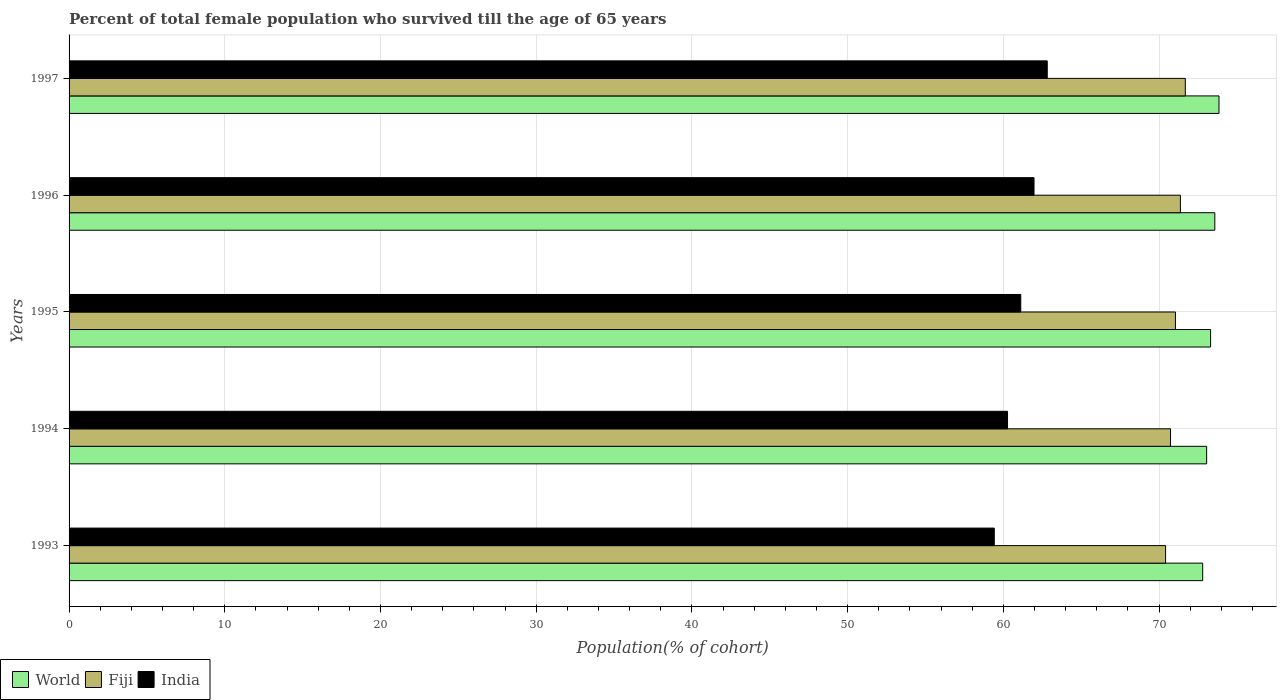Are the number of bars per tick equal to the number of legend labels?
Provide a succinct answer. Yes. How many bars are there on the 2nd tick from the top?
Offer a very short reply. 3. How many bars are there on the 5th tick from the bottom?
Make the answer very short. 3. What is the label of the 5th group of bars from the top?
Offer a terse response. 1993. What is the percentage of total female population who survived till the age of 65 years in Fiji in 1995?
Provide a short and direct response. 71.05. Across all years, what is the maximum percentage of total female population who survived till the age of 65 years in India?
Ensure brevity in your answer.  62.82. Across all years, what is the minimum percentage of total female population who survived till the age of 65 years in Fiji?
Provide a succinct answer. 70.41. In which year was the percentage of total female population who survived till the age of 65 years in India maximum?
Your answer should be compact. 1997. What is the total percentage of total female population who survived till the age of 65 years in World in the graph?
Offer a terse response. 366.57. What is the difference between the percentage of total female population who survived till the age of 65 years in India in 1993 and that in 1996?
Make the answer very short. -2.55. What is the difference between the percentage of total female population who survived till the age of 65 years in World in 1994 and the percentage of total female population who survived till the age of 65 years in Fiji in 1995?
Offer a terse response. 2. What is the average percentage of total female population who survived till the age of 65 years in Fiji per year?
Offer a terse response. 71.05. In the year 1994, what is the difference between the percentage of total female population who survived till the age of 65 years in India and percentage of total female population who survived till the age of 65 years in World?
Give a very brief answer. -12.79. What is the ratio of the percentage of total female population who survived till the age of 65 years in Fiji in 1994 to that in 1996?
Your answer should be compact. 0.99. Is the percentage of total female population who survived till the age of 65 years in India in 1996 less than that in 1997?
Your answer should be very brief. Yes. What is the difference between the highest and the second highest percentage of total female population who survived till the age of 65 years in India?
Keep it short and to the point. 0.85. What is the difference between the highest and the lowest percentage of total female population who survived till the age of 65 years in World?
Your answer should be very brief. 1.05. In how many years, is the percentage of total female population who survived till the age of 65 years in World greater than the average percentage of total female population who survived till the age of 65 years in World taken over all years?
Keep it short and to the point. 2. What does the 1st bar from the top in 1996 represents?
Your answer should be compact. India. What does the 3rd bar from the bottom in 1997 represents?
Give a very brief answer. India. Is it the case that in every year, the sum of the percentage of total female population who survived till the age of 65 years in Fiji and percentage of total female population who survived till the age of 65 years in India is greater than the percentage of total female population who survived till the age of 65 years in World?
Give a very brief answer. Yes. How many bars are there?
Give a very brief answer. 15. How many years are there in the graph?
Your answer should be very brief. 5. Are the values on the major ticks of X-axis written in scientific E-notation?
Your answer should be very brief. No. Does the graph contain grids?
Give a very brief answer. Yes. Where does the legend appear in the graph?
Provide a succinct answer. Bottom left. How many legend labels are there?
Offer a very short reply. 3. What is the title of the graph?
Make the answer very short. Percent of total female population who survived till the age of 65 years. Does "Sri Lanka" appear as one of the legend labels in the graph?
Your answer should be compact. No. What is the label or title of the X-axis?
Your answer should be compact. Population(% of cohort). What is the label or title of the Y-axis?
Provide a short and direct response. Years. What is the Population(% of cohort) in World in 1993?
Give a very brief answer. 72.8. What is the Population(% of cohort) in Fiji in 1993?
Offer a terse response. 70.41. What is the Population(% of cohort) in India in 1993?
Provide a short and direct response. 59.41. What is the Population(% of cohort) in World in 1994?
Offer a very short reply. 73.05. What is the Population(% of cohort) of Fiji in 1994?
Ensure brevity in your answer.  70.73. What is the Population(% of cohort) of India in 1994?
Offer a very short reply. 60.26. What is the Population(% of cohort) in World in 1995?
Make the answer very short. 73.3. What is the Population(% of cohort) of Fiji in 1995?
Make the answer very short. 71.05. What is the Population(% of cohort) of India in 1995?
Your answer should be very brief. 61.11. What is the Population(% of cohort) in World in 1996?
Your answer should be very brief. 73.58. What is the Population(% of cohort) in Fiji in 1996?
Provide a short and direct response. 71.36. What is the Population(% of cohort) of India in 1996?
Keep it short and to the point. 61.97. What is the Population(% of cohort) of World in 1997?
Your answer should be compact. 73.84. What is the Population(% of cohort) of Fiji in 1997?
Make the answer very short. 71.68. What is the Population(% of cohort) in India in 1997?
Your response must be concise. 62.82. Across all years, what is the maximum Population(% of cohort) of World?
Your answer should be very brief. 73.84. Across all years, what is the maximum Population(% of cohort) in Fiji?
Make the answer very short. 71.68. Across all years, what is the maximum Population(% of cohort) in India?
Ensure brevity in your answer.  62.82. Across all years, what is the minimum Population(% of cohort) in World?
Your answer should be very brief. 72.8. Across all years, what is the minimum Population(% of cohort) in Fiji?
Your answer should be very brief. 70.41. Across all years, what is the minimum Population(% of cohort) of India?
Your answer should be compact. 59.41. What is the total Population(% of cohort) of World in the graph?
Your answer should be compact. 366.57. What is the total Population(% of cohort) in Fiji in the graph?
Provide a succinct answer. 355.24. What is the total Population(% of cohort) in India in the graph?
Keep it short and to the point. 305.57. What is the difference between the Population(% of cohort) of World in 1993 and that in 1994?
Provide a short and direct response. -0.25. What is the difference between the Population(% of cohort) in Fiji in 1993 and that in 1994?
Your answer should be very brief. -0.32. What is the difference between the Population(% of cohort) of India in 1993 and that in 1994?
Your answer should be compact. -0.85. What is the difference between the Population(% of cohort) in World in 1993 and that in 1995?
Your answer should be very brief. -0.51. What is the difference between the Population(% of cohort) of Fiji in 1993 and that in 1995?
Keep it short and to the point. -0.63. What is the difference between the Population(% of cohort) of India in 1993 and that in 1995?
Give a very brief answer. -1.7. What is the difference between the Population(% of cohort) in World in 1993 and that in 1996?
Make the answer very short. -0.78. What is the difference between the Population(% of cohort) of Fiji in 1993 and that in 1996?
Your response must be concise. -0.95. What is the difference between the Population(% of cohort) of India in 1993 and that in 1996?
Your response must be concise. -2.55. What is the difference between the Population(% of cohort) of World in 1993 and that in 1997?
Your answer should be compact. -1.05. What is the difference between the Population(% of cohort) in Fiji in 1993 and that in 1997?
Your answer should be very brief. -1.27. What is the difference between the Population(% of cohort) of India in 1993 and that in 1997?
Make the answer very short. -3.4. What is the difference between the Population(% of cohort) of World in 1994 and that in 1995?
Make the answer very short. -0.25. What is the difference between the Population(% of cohort) in Fiji in 1994 and that in 1995?
Give a very brief answer. -0.32. What is the difference between the Population(% of cohort) in India in 1994 and that in 1995?
Provide a short and direct response. -0.85. What is the difference between the Population(% of cohort) of World in 1994 and that in 1996?
Keep it short and to the point. -0.53. What is the difference between the Population(% of cohort) in Fiji in 1994 and that in 1996?
Offer a very short reply. -0.63. What is the difference between the Population(% of cohort) of India in 1994 and that in 1996?
Ensure brevity in your answer.  -1.7. What is the difference between the Population(% of cohort) of World in 1994 and that in 1997?
Give a very brief answer. -0.79. What is the difference between the Population(% of cohort) in Fiji in 1994 and that in 1997?
Your response must be concise. -0.95. What is the difference between the Population(% of cohort) in India in 1994 and that in 1997?
Give a very brief answer. -2.55. What is the difference between the Population(% of cohort) in World in 1995 and that in 1996?
Your answer should be very brief. -0.27. What is the difference between the Population(% of cohort) of Fiji in 1995 and that in 1996?
Offer a terse response. -0.32. What is the difference between the Population(% of cohort) in India in 1995 and that in 1996?
Offer a terse response. -0.85. What is the difference between the Population(% of cohort) in World in 1995 and that in 1997?
Your answer should be compact. -0.54. What is the difference between the Population(% of cohort) in Fiji in 1995 and that in 1997?
Make the answer very short. -0.63. What is the difference between the Population(% of cohort) in India in 1995 and that in 1997?
Keep it short and to the point. -1.7. What is the difference between the Population(% of cohort) of World in 1996 and that in 1997?
Keep it short and to the point. -0.27. What is the difference between the Population(% of cohort) in Fiji in 1996 and that in 1997?
Your response must be concise. -0.32. What is the difference between the Population(% of cohort) in India in 1996 and that in 1997?
Your answer should be very brief. -0.85. What is the difference between the Population(% of cohort) of World in 1993 and the Population(% of cohort) of Fiji in 1994?
Offer a terse response. 2.07. What is the difference between the Population(% of cohort) of World in 1993 and the Population(% of cohort) of India in 1994?
Your answer should be very brief. 12.53. What is the difference between the Population(% of cohort) of Fiji in 1993 and the Population(% of cohort) of India in 1994?
Offer a very short reply. 10.15. What is the difference between the Population(% of cohort) of World in 1993 and the Population(% of cohort) of Fiji in 1995?
Give a very brief answer. 1.75. What is the difference between the Population(% of cohort) in World in 1993 and the Population(% of cohort) in India in 1995?
Offer a very short reply. 11.68. What is the difference between the Population(% of cohort) of Fiji in 1993 and the Population(% of cohort) of India in 1995?
Offer a terse response. 9.3. What is the difference between the Population(% of cohort) of World in 1993 and the Population(% of cohort) of Fiji in 1996?
Offer a terse response. 1.43. What is the difference between the Population(% of cohort) in World in 1993 and the Population(% of cohort) in India in 1996?
Your answer should be very brief. 10.83. What is the difference between the Population(% of cohort) of Fiji in 1993 and the Population(% of cohort) of India in 1996?
Offer a terse response. 8.45. What is the difference between the Population(% of cohort) of World in 1993 and the Population(% of cohort) of Fiji in 1997?
Keep it short and to the point. 1.12. What is the difference between the Population(% of cohort) in World in 1993 and the Population(% of cohort) in India in 1997?
Ensure brevity in your answer.  9.98. What is the difference between the Population(% of cohort) in Fiji in 1993 and the Population(% of cohort) in India in 1997?
Your answer should be compact. 7.6. What is the difference between the Population(% of cohort) in World in 1994 and the Population(% of cohort) in Fiji in 1995?
Offer a very short reply. 2. What is the difference between the Population(% of cohort) in World in 1994 and the Population(% of cohort) in India in 1995?
Keep it short and to the point. 11.94. What is the difference between the Population(% of cohort) in Fiji in 1994 and the Population(% of cohort) in India in 1995?
Ensure brevity in your answer.  9.62. What is the difference between the Population(% of cohort) in World in 1994 and the Population(% of cohort) in Fiji in 1996?
Offer a very short reply. 1.69. What is the difference between the Population(% of cohort) of World in 1994 and the Population(% of cohort) of India in 1996?
Make the answer very short. 11.09. What is the difference between the Population(% of cohort) in Fiji in 1994 and the Population(% of cohort) in India in 1996?
Offer a terse response. 8.77. What is the difference between the Population(% of cohort) in World in 1994 and the Population(% of cohort) in Fiji in 1997?
Offer a very short reply. 1.37. What is the difference between the Population(% of cohort) of World in 1994 and the Population(% of cohort) of India in 1997?
Your answer should be very brief. 10.24. What is the difference between the Population(% of cohort) of Fiji in 1994 and the Population(% of cohort) of India in 1997?
Your answer should be compact. 7.92. What is the difference between the Population(% of cohort) of World in 1995 and the Population(% of cohort) of Fiji in 1996?
Keep it short and to the point. 1.94. What is the difference between the Population(% of cohort) of World in 1995 and the Population(% of cohort) of India in 1996?
Provide a succinct answer. 11.34. What is the difference between the Population(% of cohort) in Fiji in 1995 and the Population(% of cohort) in India in 1996?
Ensure brevity in your answer.  9.08. What is the difference between the Population(% of cohort) in World in 1995 and the Population(% of cohort) in Fiji in 1997?
Provide a succinct answer. 1.62. What is the difference between the Population(% of cohort) in World in 1995 and the Population(% of cohort) in India in 1997?
Offer a terse response. 10.49. What is the difference between the Population(% of cohort) of Fiji in 1995 and the Population(% of cohort) of India in 1997?
Offer a terse response. 8.23. What is the difference between the Population(% of cohort) of World in 1996 and the Population(% of cohort) of Fiji in 1997?
Provide a succinct answer. 1.89. What is the difference between the Population(% of cohort) in World in 1996 and the Population(% of cohort) in India in 1997?
Give a very brief answer. 10.76. What is the difference between the Population(% of cohort) of Fiji in 1996 and the Population(% of cohort) of India in 1997?
Make the answer very short. 8.55. What is the average Population(% of cohort) in World per year?
Give a very brief answer. 73.31. What is the average Population(% of cohort) of Fiji per year?
Your answer should be compact. 71.05. What is the average Population(% of cohort) of India per year?
Provide a succinct answer. 61.11. In the year 1993, what is the difference between the Population(% of cohort) of World and Population(% of cohort) of Fiji?
Offer a terse response. 2.38. In the year 1993, what is the difference between the Population(% of cohort) in World and Population(% of cohort) in India?
Your answer should be compact. 13.38. In the year 1993, what is the difference between the Population(% of cohort) of Fiji and Population(% of cohort) of India?
Offer a very short reply. 11. In the year 1994, what is the difference between the Population(% of cohort) of World and Population(% of cohort) of Fiji?
Keep it short and to the point. 2.32. In the year 1994, what is the difference between the Population(% of cohort) of World and Population(% of cohort) of India?
Give a very brief answer. 12.79. In the year 1994, what is the difference between the Population(% of cohort) in Fiji and Population(% of cohort) in India?
Keep it short and to the point. 10.47. In the year 1995, what is the difference between the Population(% of cohort) in World and Population(% of cohort) in Fiji?
Your response must be concise. 2.26. In the year 1995, what is the difference between the Population(% of cohort) of World and Population(% of cohort) of India?
Make the answer very short. 12.19. In the year 1995, what is the difference between the Population(% of cohort) of Fiji and Population(% of cohort) of India?
Make the answer very short. 9.93. In the year 1996, what is the difference between the Population(% of cohort) in World and Population(% of cohort) in Fiji?
Offer a terse response. 2.21. In the year 1996, what is the difference between the Population(% of cohort) of World and Population(% of cohort) of India?
Your answer should be compact. 11.61. In the year 1996, what is the difference between the Population(% of cohort) of Fiji and Population(% of cohort) of India?
Your answer should be very brief. 9.4. In the year 1997, what is the difference between the Population(% of cohort) of World and Population(% of cohort) of Fiji?
Your answer should be compact. 2.16. In the year 1997, what is the difference between the Population(% of cohort) of World and Population(% of cohort) of India?
Make the answer very short. 11.03. In the year 1997, what is the difference between the Population(% of cohort) in Fiji and Population(% of cohort) in India?
Your response must be concise. 8.87. What is the ratio of the Population(% of cohort) in World in 1993 to that in 1994?
Keep it short and to the point. 1. What is the ratio of the Population(% of cohort) of India in 1993 to that in 1994?
Your answer should be very brief. 0.99. What is the ratio of the Population(% of cohort) of World in 1993 to that in 1995?
Make the answer very short. 0.99. What is the ratio of the Population(% of cohort) in India in 1993 to that in 1995?
Provide a succinct answer. 0.97. What is the ratio of the Population(% of cohort) in Fiji in 1993 to that in 1996?
Your answer should be very brief. 0.99. What is the ratio of the Population(% of cohort) in India in 1993 to that in 1996?
Offer a very short reply. 0.96. What is the ratio of the Population(% of cohort) in World in 1993 to that in 1997?
Your answer should be compact. 0.99. What is the ratio of the Population(% of cohort) of Fiji in 1993 to that in 1997?
Your answer should be very brief. 0.98. What is the ratio of the Population(% of cohort) in India in 1993 to that in 1997?
Provide a short and direct response. 0.95. What is the ratio of the Population(% of cohort) of India in 1994 to that in 1995?
Your answer should be very brief. 0.99. What is the ratio of the Population(% of cohort) of World in 1994 to that in 1996?
Give a very brief answer. 0.99. What is the ratio of the Population(% of cohort) in Fiji in 1994 to that in 1996?
Provide a succinct answer. 0.99. What is the ratio of the Population(% of cohort) in India in 1994 to that in 1996?
Offer a very short reply. 0.97. What is the ratio of the Population(% of cohort) in World in 1994 to that in 1997?
Your answer should be compact. 0.99. What is the ratio of the Population(% of cohort) in Fiji in 1994 to that in 1997?
Ensure brevity in your answer.  0.99. What is the ratio of the Population(% of cohort) of India in 1994 to that in 1997?
Provide a short and direct response. 0.96. What is the ratio of the Population(% of cohort) in World in 1995 to that in 1996?
Offer a terse response. 1. What is the ratio of the Population(% of cohort) of Fiji in 1995 to that in 1996?
Offer a terse response. 1. What is the ratio of the Population(% of cohort) in India in 1995 to that in 1996?
Ensure brevity in your answer.  0.99. What is the ratio of the Population(% of cohort) of World in 1995 to that in 1997?
Your response must be concise. 0.99. What is the ratio of the Population(% of cohort) of Fiji in 1995 to that in 1997?
Offer a terse response. 0.99. What is the ratio of the Population(% of cohort) of India in 1995 to that in 1997?
Give a very brief answer. 0.97. What is the ratio of the Population(% of cohort) of India in 1996 to that in 1997?
Your answer should be very brief. 0.99. What is the difference between the highest and the second highest Population(% of cohort) of World?
Your answer should be very brief. 0.27. What is the difference between the highest and the second highest Population(% of cohort) of Fiji?
Offer a very short reply. 0.32. What is the difference between the highest and the second highest Population(% of cohort) in India?
Your answer should be very brief. 0.85. What is the difference between the highest and the lowest Population(% of cohort) in World?
Ensure brevity in your answer.  1.05. What is the difference between the highest and the lowest Population(% of cohort) in Fiji?
Your answer should be very brief. 1.27. What is the difference between the highest and the lowest Population(% of cohort) in India?
Your response must be concise. 3.4. 